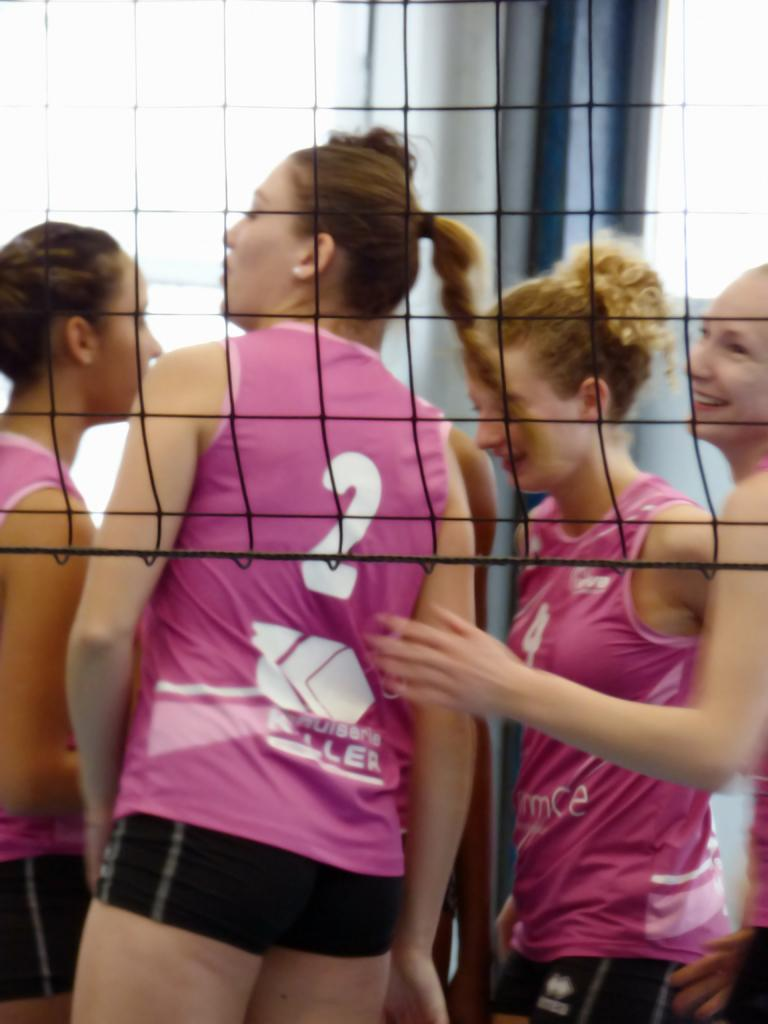Who is present in the image? There are women in the image. What are the women doing in the image? The women are standing through a sports net. What type of breakfast is being served on the desk in the image? There is no mention of a desk or breakfast in the image; it only features women standing through a sports net. 